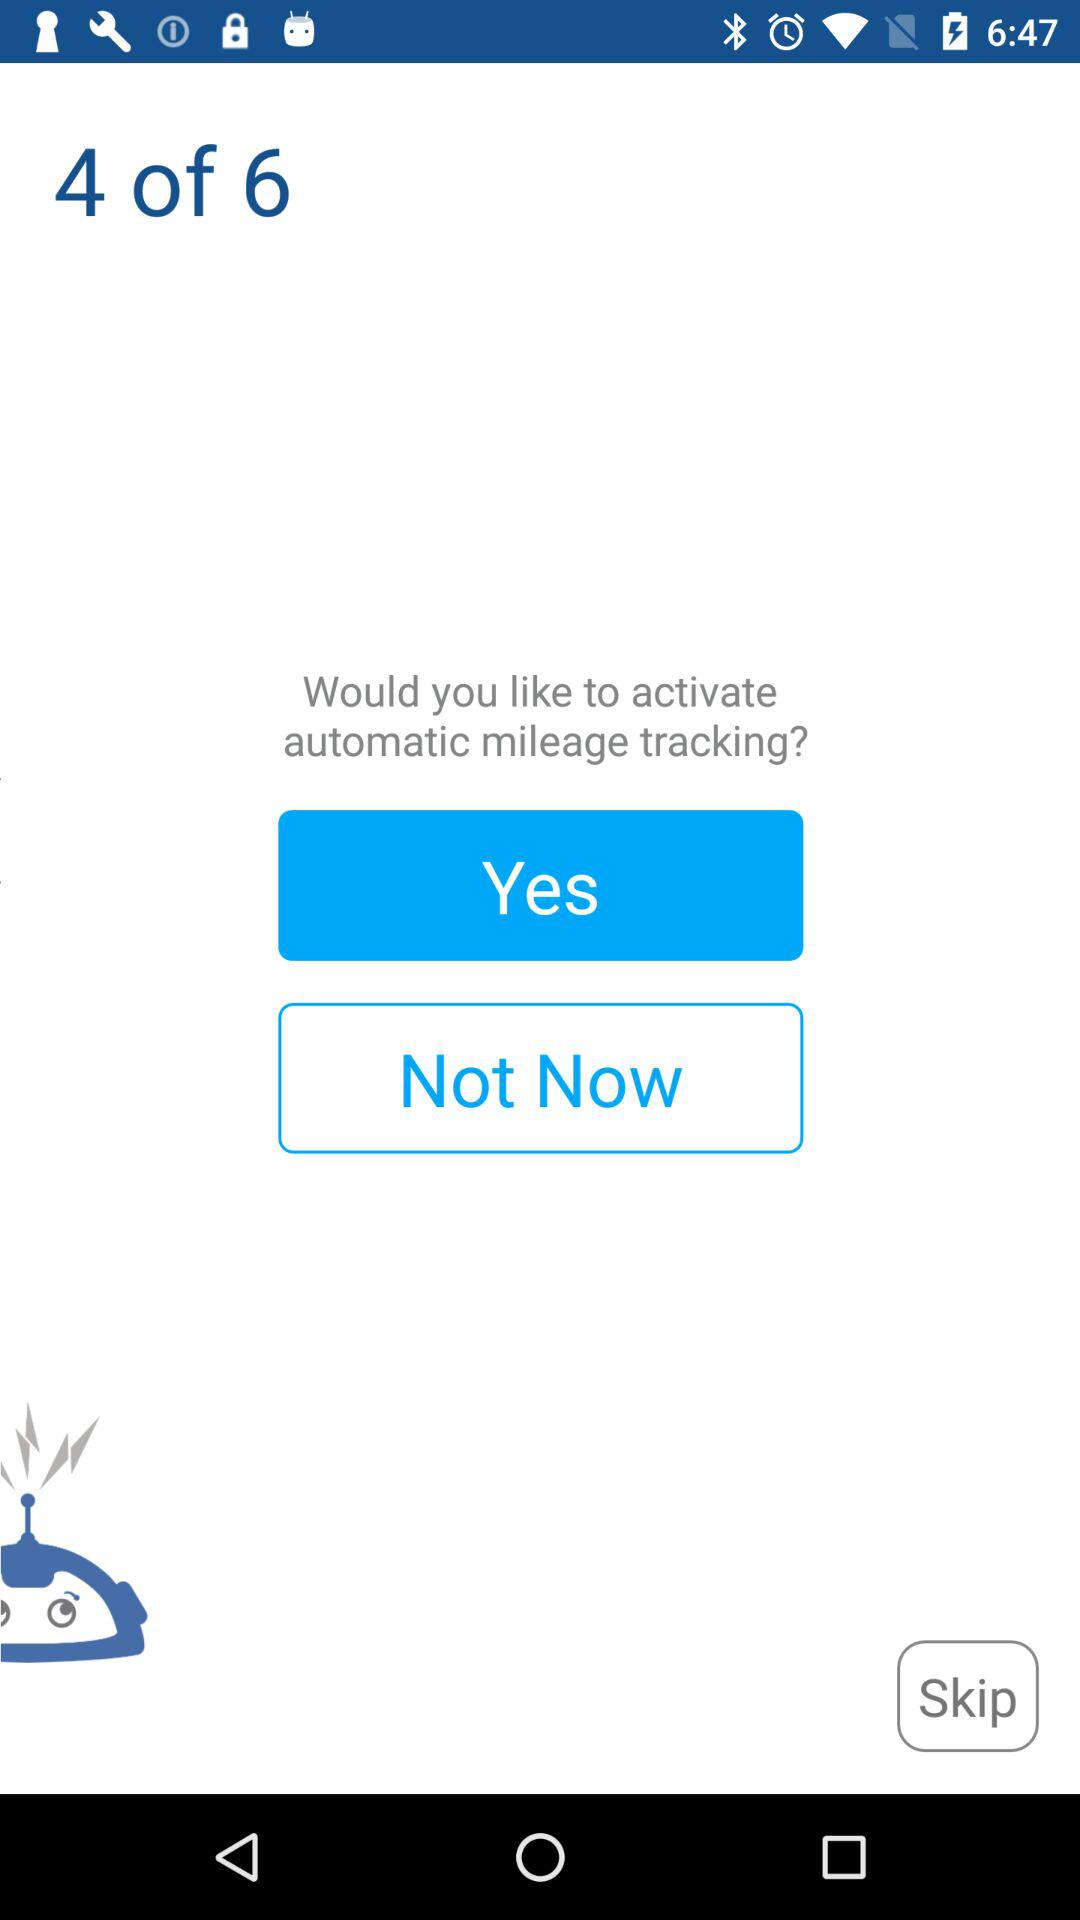How many total pages are there? There are 6 pages. 